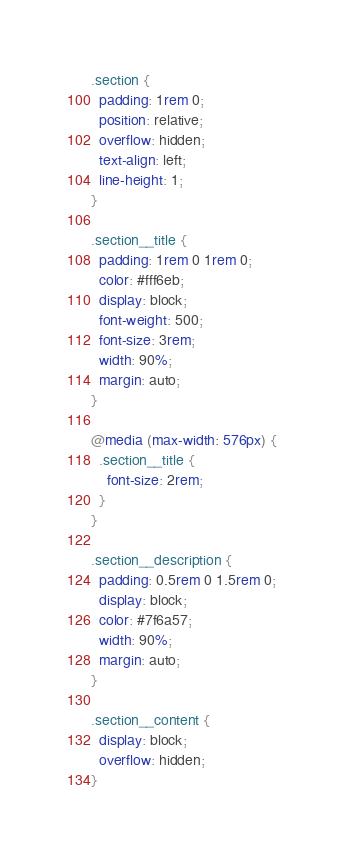<code> <loc_0><loc_0><loc_500><loc_500><_CSS_>.section {
  padding: 1rem 0;
  position: relative;
  overflow: hidden;
  text-align: left;
  line-height: 1;
}

.section__title {
  padding: 1rem 0 1rem 0;
  color: #fff6eb;
  display: block;
  font-weight: 500;
  font-size: 3rem;
  width: 90%;
  margin: auto;
}

@media (max-width: 576px) {
  .section__title {
    font-size: 2rem;
  }
}

.section__description {
  padding: 0.5rem 0 1.5rem 0;
  display: block;
  color: #7f6a57;
  width: 90%;
  margin: auto;
}

.section__content {
  display: block;
  overflow: hidden;
}
</code> 